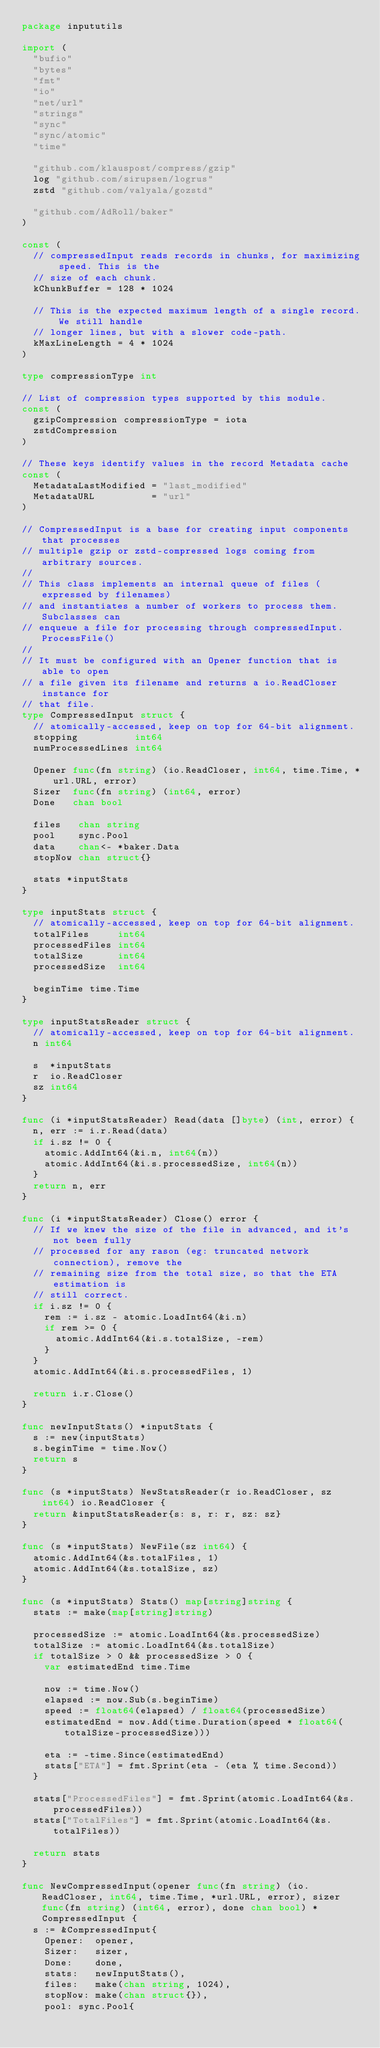Convert code to text. <code><loc_0><loc_0><loc_500><loc_500><_Go_>package inpututils

import (
	"bufio"
	"bytes"
	"fmt"
	"io"
	"net/url"
	"strings"
	"sync"
	"sync/atomic"
	"time"

	"github.com/klauspost/compress/gzip"
	log "github.com/sirupsen/logrus"
	zstd "github.com/valyala/gozstd"

	"github.com/AdRoll/baker"
)

const (
	// compressedInput reads records in chunks, for maximizing speed. This is the
	// size of each chunk.
	kChunkBuffer = 128 * 1024

	// This is the expected maximum length of a single record. We still handle
	// longer lines, but with a slower code-path.
	kMaxLineLength = 4 * 1024
)

type compressionType int

// List of compression types supported by this module.
const (
	gzipCompression compressionType = iota
	zstdCompression
)

// These keys identify values in the record Metadata cache
const (
	MetadataLastModified = "last_modified"
	MetadataURL          = "url"
)

// CompressedInput is a base for creating input components that processes
// multiple gzip or zstd-compressed logs coming from arbitrary sources.
//
// This class implements an internal queue of files (expressed by filenames)
// and instantiates a number of workers to process them. Subclasses can
// enqueue a file for processing through compressedInput.ProcessFile()
//
// It must be configured with an Opener function that is able to open
// a file given its filename and returns a io.ReadCloser instance for
// that file.
type CompressedInput struct {
	// atomically-accessed, keep on top for 64-bit alignment.
	stopping          int64
	numProcessedLines int64

	Opener func(fn string) (io.ReadCloser, int64, time.Time, *url.URL, error)
	Sizer  func(fn string) (int64, error)
	Done   chan bool

	files   chan string
	pool    sync.Pool
	data    chan<- *baker.Data
	stopNow chan struct{}

	stats *inputStats
}

type inputStats struct {
	// atomically-accessed, keep on top for 64-bit alignment.
	totalFiles     int64
	processedFiles int64
	totalSize      int64
	processedSize  int64

	beginTime time.Time
}

type inputStatsReader struct {
	// atomically-accessed, keep on top for 64-bit alignment.
	n int64

	s  *inputStats
	r  io.ReadCloser
	sz int64
}

func (i *inputStatsReader) Read(data []byte) (int, error) {
	n, err := i.r.Read(data)
	if i.sz != 0 {
		atomic.AddInt64(&i.n, int64(n))
		atomic.AddInt64(&i.s.processedSize, int64(n))
	}
	return n, err
}

func (i *inputStatsReader) Close() error {
	// If we knew the size of the file in advanced, and it's not been fully
	// processed for any rason (eg: truncated network connection), remove the
	// remaining size from the total size, so that the ETA estimation is
	// still correct.
	if i.sz != 0 {
		rem := i.sz - atomic.LoadInt64(&i.n)
		if rem >= 0 {
			atomic.AddInt64(&i.s.totalSize, -rem)
		}
	}
	atomic.AddInt64(&i.s.processedFiles, 1)

	return i.r.Close()
}

func newInputStats() *inputStats {
	s := new(inputStats)
	s.beginTime = time.Now()
	return s
}

func (s *inputStats) NewStatsReader(r io.ReadCloser, sz int64) io.ReadCloser {
	return &inputStatsReader{s: s, r: r, sz: sz}
}

func (s *inputStats) NewFile(sz int64) {
	atomic.AddInt64(&s.totalFiles, 1)
	atomic.AddInt64(&s.totalSize, sz)
}

func (s *inputStats) Stats() map[string]string {
	stats := make(map[string]string)

	processedSize := atomic.LoadInt64(&s.processedSize)
	totalSize := atomic.LoadInt64(&s.totalSize)
	if totalSize > 0 && processedSize > 0 {
		var estimatedEnd time.Time

		now := time.Now()
		elapsed := now.Sub(s.beginTime)
		speed := float64(elapsed) / float64(processedSize)
		estimatedEnd = now.Add(time.Duration(speed * float64(totalSize-processedSize)))

		eta := -time.Since(estimatedEnd)
		stats["ETA"] = fmt.Sprint(eta - (eta % time.Second))
	}

	stats["ProcessedFiles"] = fmt.Sprint(atomic.LoadInt64(&s.processedFiles))
	stats["TotalFiles"] = fmt.Sprint(atomic.LoadInt64(&s.totalFiles))

	return stats
}

func NewCompressedInput(opener func(fn string) (io.ReadCloser, int64, time.Time, *url.URL, error), sizer func(fn string) (int64, error), done chan bool) *CompressedInput {
	s := &CompressedInput{
		Opener:  opener,
		Sizer:   sizer,
		Done:    done,
		stats:   newInputStats(),
		files:   make(chan string, 1024),
		stopNow: make(chan struct{}),
		pool: sync.Pool{</code> 